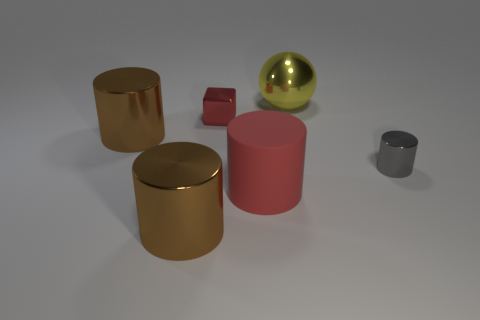There is a red metal object that is the same size as the gray object; what is its shape?
Ensure brevity in your answer.  Cube. Is there a tiny cyan thing that has the same shape as the gray object?
Give a very brief answer. No. There is a brown thing behind the red object in front of the tiny cube; is there a large yellow metallic ball that is in front of it?
Keep it short and to the point. No. Are there more large metallic things to the right of the gray cylinder than yellow shiny objects that are to the left of the red cylinder?
Make the answer very short. No. There is a ball that is the same size as the red rubber thing; what is it made of?
Keep it short and to the point. Metal. What number of large objects are either cubes or red things?
Provide a short and direct response. 1. Is the big rubber thing the same shape as the gray shiny thing?
Give a very brief answer. Yes. How many shiny things are both left of the big yellow thing and in front of the red shiny object?
Your answer should be compact. 2. Is there anything else of the same color as the matte thing?
Provide a succinct answer. Yes. What is the shape of the yellow thing that is made of the same material as the small gray cylinder?
Provide a short and direct response. Sphere. 